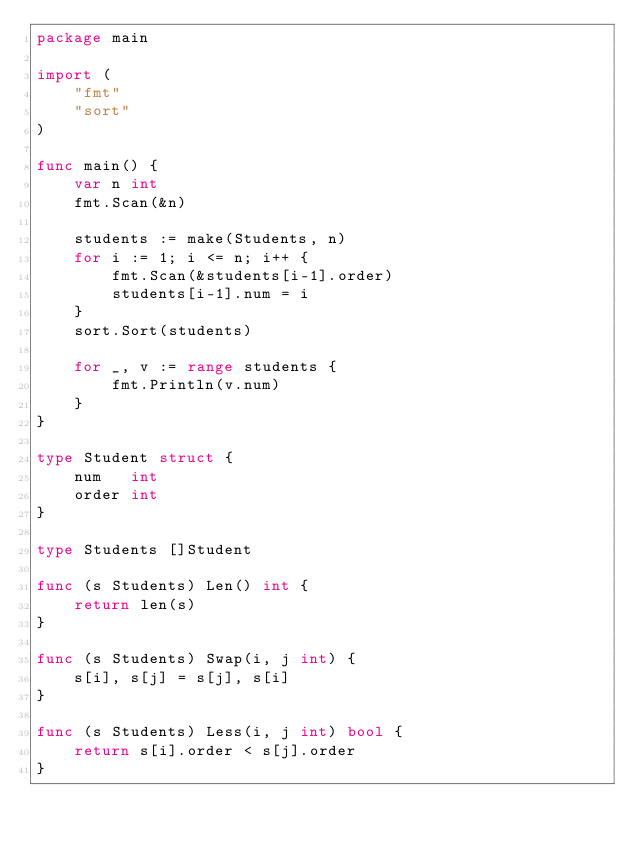<code> <loc_0><loc_0><loc_500><loc_500><_Go_>package main

import (
	"fmt"
	"sort"
)

func main() {
	var n int
	fmt.Scan(&n)

	students := make(Students, n)
	for i := 1; i <= n; i++ {
		fmt.Scan(&students[i-1].order)
		students[i-1].num = i
	}
	sort.Sort(students)

	for _, v := range students {
		fmt.Println(v.num)
	}
}

type Student struct {
	num   int
	order int
}

type Students []Student

func (s Students) Len() int {
	return len(s)
}

func (s Students) Swap(i, j int) {
	s[i], s[j] = s[j], s[i]
}

func (s Students) Less(i, j int) bool {
	return s[i].order < s[j].order
}
</code> 